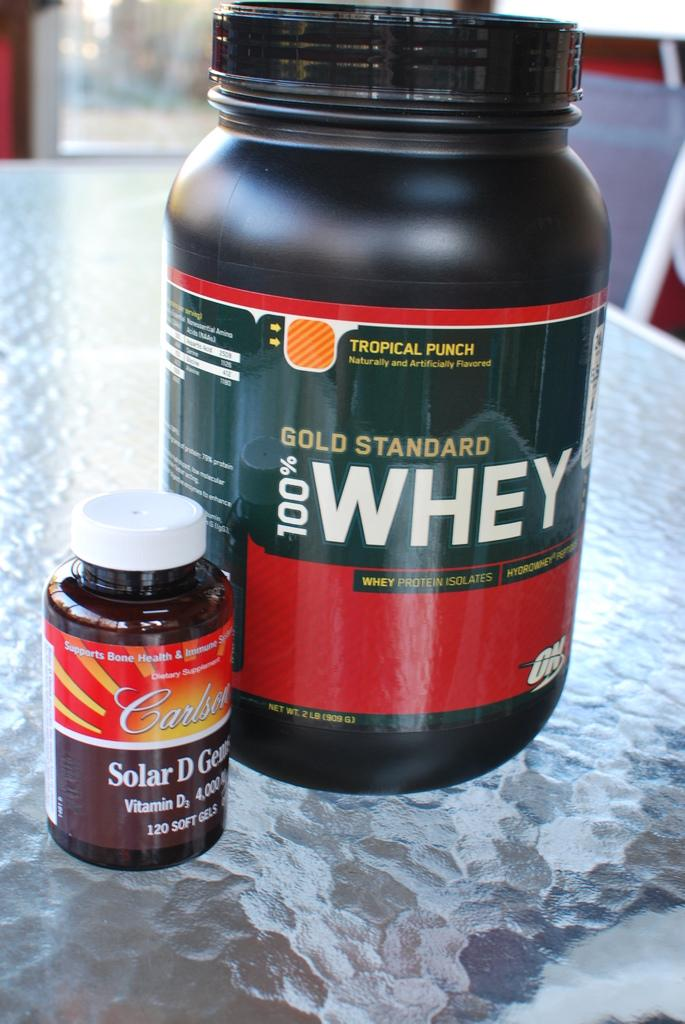Provide a one-sentence caption for the provided image. A Bold Standard 100% whey bottle sits next to a small vitamin bottle. 